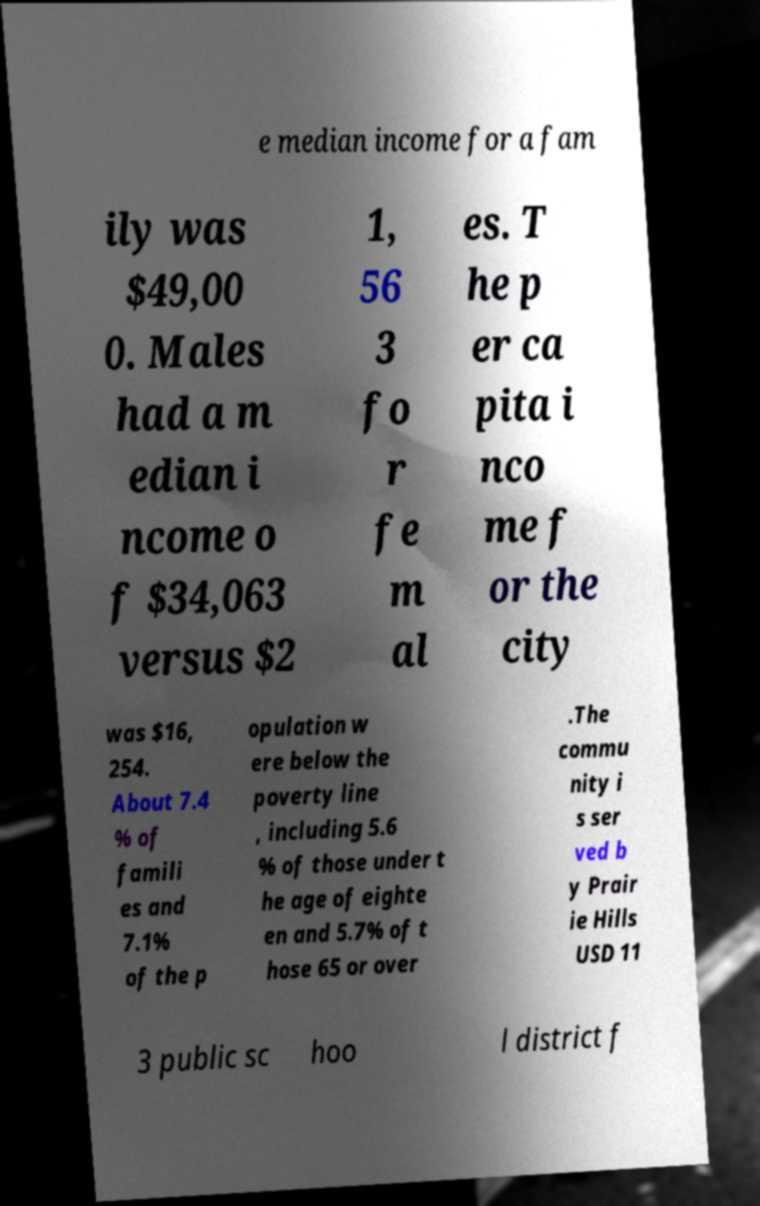Can you accurately transcribe the text from the provided image for me? e median income for a fam ily was $49,00 0. Males had a m edian i ncome o f $34,063 versus $2 1, 56 3 fo r fe m al es. T he p er ca pita i nco me f or the city was $16, 254. About 7.4 % of famili es and 7.1% of the p opulation w ere below the poverty line , including 5.6 % of those under t he age of eighte en and 5.7% of t hose 65 or over .The commu nity i s ser ved b y Prair ie Hills USD 11 3 public sc hoo l district f 